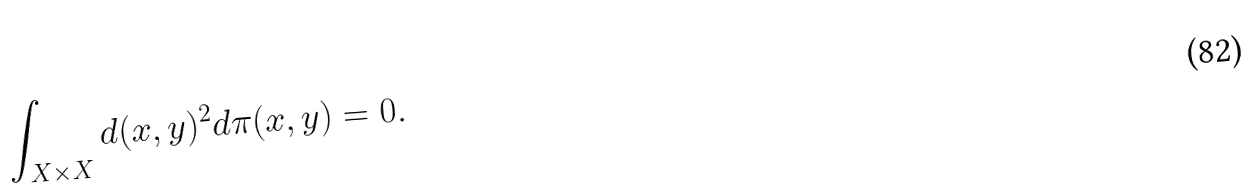Convert formula to latex. <formula><loc_0><loc_0><loc_500><loc_500>\int _ { X \times X } d ( x , y ) ^ { 2 } d \pi ( x , y ) = 0 .</formula> 